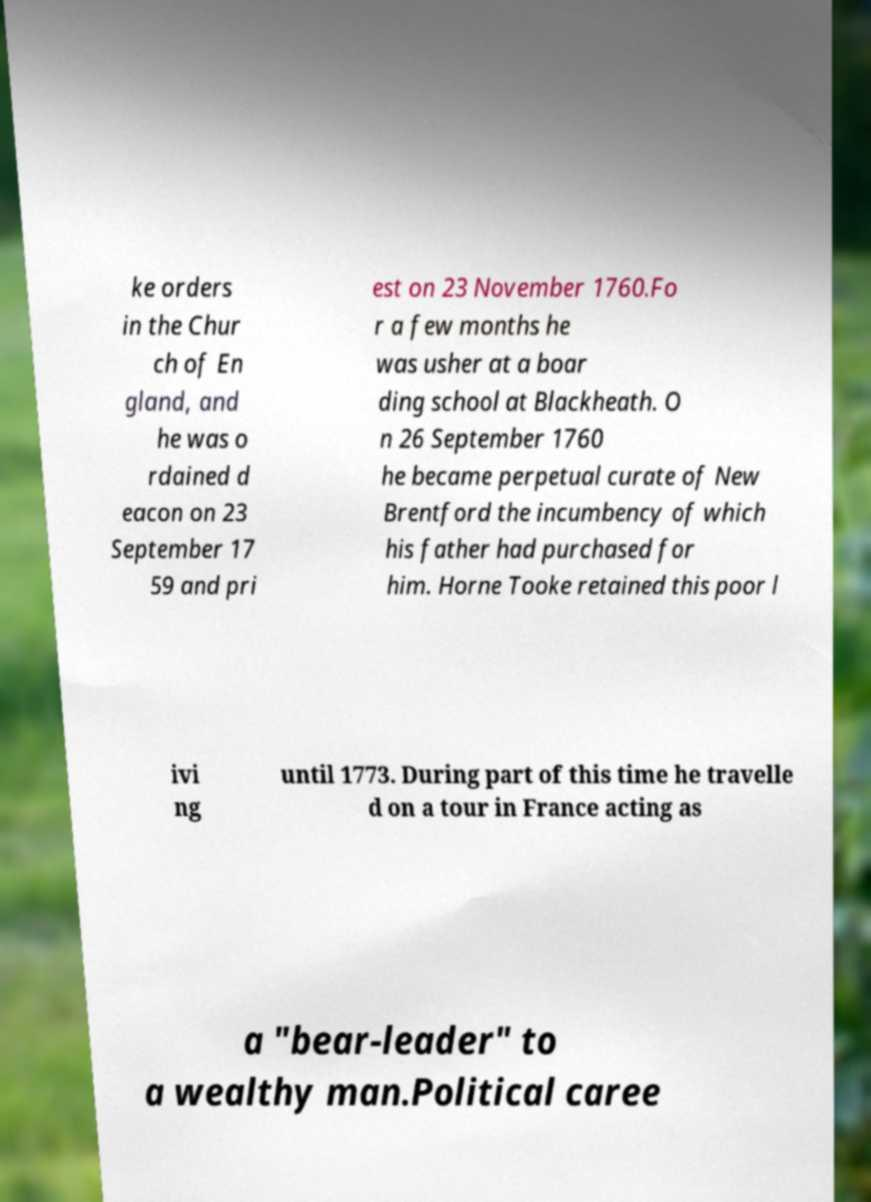Could you extract and type out the text from this image? ke orders in the Chur ch of En gland, and he was o rdained d eacon on 23 September 17 59 and pri est on 23 November 1760.Fo r a few months he was usher at a boar ding school at Blackheath. O n 26 September 1760 he became perpetual curate of New Brentford the incumbency of which his father had purchased for him. Horne Tooke retained this poor l ivi ng until 1773. During part of this time he travelle d on a tour in France acting as a "bear-leader" to a wealthy man.Political caree 